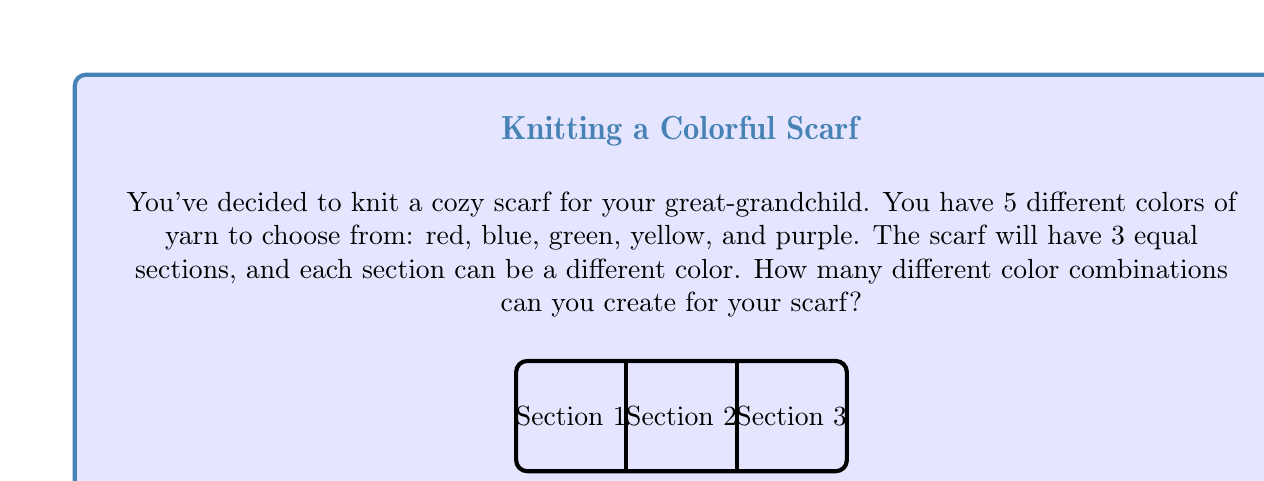Could you help me with this problem? Let's approach this step-by-step:

1) First, we need to understand what the question is asking. We're choosing a color for each of the 3 sections of the scarf, and we can use any of the 5 colors for each section.

2) This is a problem of combinations with repetition allowed. We can use the same color multiple times if we want.

3) For each section, we have 5 choices of color. This is true for all 3 sections independently.

4) In combinatorics, when we have a series of independent choices, we multiply the number of options for each choice. This is known as the multiplication principle.

5) Therefore, the total number of possible combinations is:

   $$ 5 \times 5 \times 5 = 5^3 = 125 $$

6) We can also think about this as creating a 3-digit number where each digit can be from 1 to 5. This would also give us $5^3$ possibilities.

Thus, you can create 125 different color combinations for your scarf.
Answer: $5^3 = 125$ combinations 